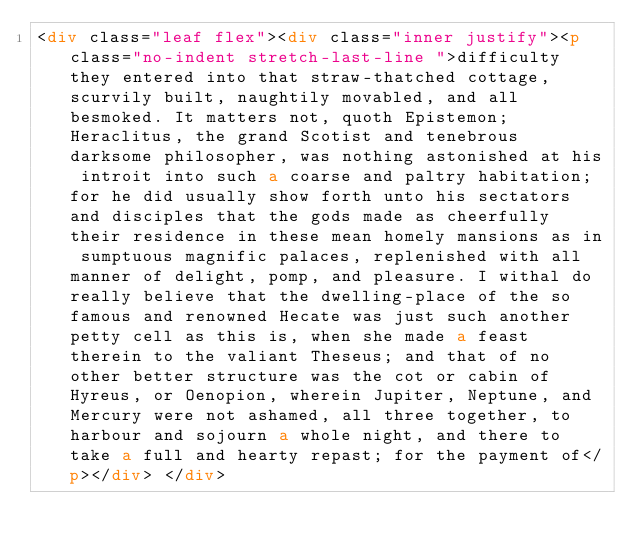Convert code to text. <code><loc_0><loc_0><loc_500><loc_500><_HTML_><div class="leaf flex"><div class="inner justify"><p class="no-indent stretch-last-line ">difficulty they entered into that straw-thatched cottage, scurvily built, naughtily movabled, and all besmoked. It matters not, quoth Epistemon; Heraclitus, the grand Scotist and tenebrous darksome philosopher, was nothing astonished at his introit into such a coarse and paltry habitation; for he did usually show forth unto his sectators and disciples that the gods made as cheerfully their residence in these mean homely mansions as in sumptuous magnific palaces, replenished with all manner of delight, pomp, and pleasure. I withal do really believe that the dwelling-place of the so famous and renowned Hecate was just such another petty cell as this is, when she made a feast therein to the valiant Theseus; and that of no other better structure was the cot or cabin of Hyreus, or Oenopion, wherein Jupiter, Neptune, and Mercury were not ashamed, all three together, to harbour and sojourn a whole night, and there to take a full and hearty repast; for the payment of</p></div> </div></code> 